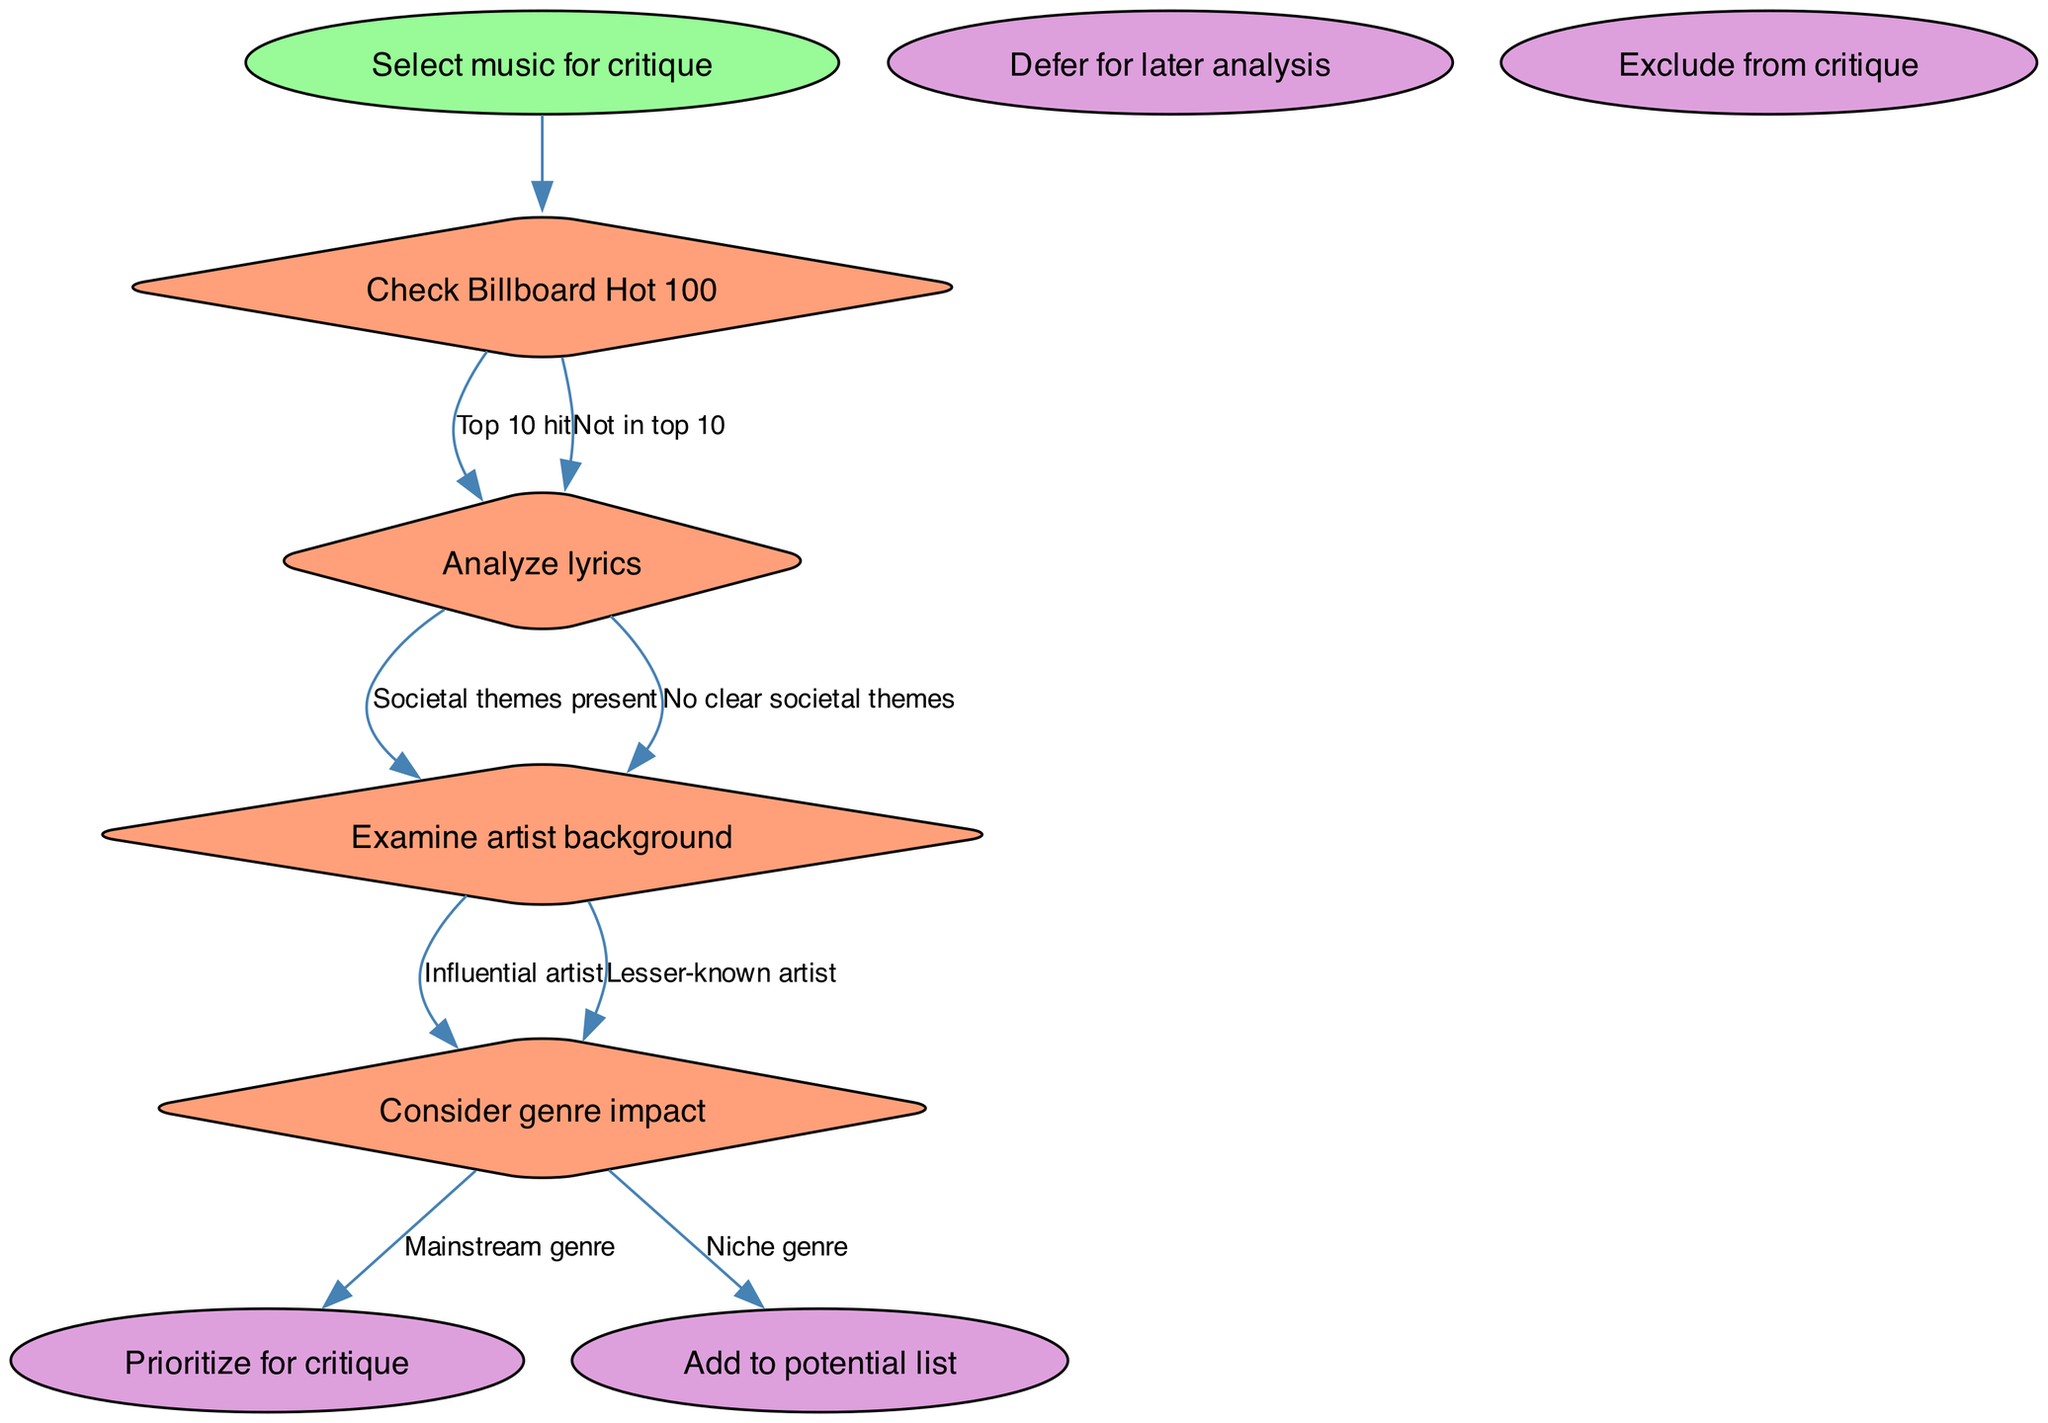What is the starting node of the flow chart? The starting node is labeled "Select music for critique," which signifies the initial action in the decision-making process.
Answer: Select music for critique How many end nodes are there in the diagram? There are four end nodes listed at the end of the flow chart, indicating the various outcomes of the decision-making process.
Answer: 4 What is one possible outcome after analyzing lyrics? After analyzing lyrics, one potential outcome is "Prioritize for critique," which suggests that sufficient societal themes warrant immediate evaluation.
Answer: Prioritize for critique If the music is a "Top 10 hit," what is the next decision to make? If the music is identified as a "Top 10 hit," the decision proceeds to analyze the lyrics, determining if societal themes are present or absent.
Answer: Analyze lyrics What node follows if the artist is verified as an "Influential artist"? If the artist is determined to be "Influential," the next decision to consider involves examining the genre's impact, assessing whether it falls under a mainstream or niche genre.
Answer: Consider genre impact How many options are there after checking the Billboard Hot 100? After checking the Billboard Hot 100, there are two options: "Top 10 hit" and "Not in top 10," indicating the binary decision facing the evaluator.
Answer: 2 What happens after considering genre impact? Following the consideration of genre impact, outcomes can lead to one of the four end nodes based on the prior analysis, guiding the final critique decision.
Answer: Outcomes lead to end nodes If the decision is based on "No clear societal themes," what would the end result be? If "No clear societal themes" is identified in the lyrics analysis, the logical end result would be to "Exclude from critique," as it lacks significant societal relevance.
Answer: Exclude from critique 